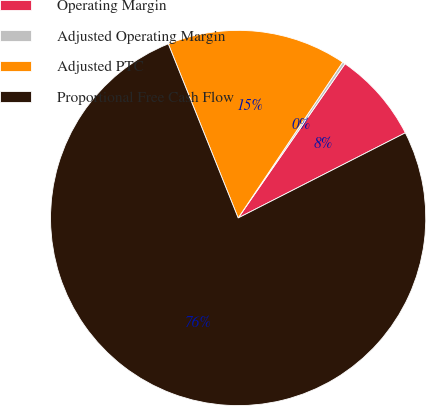Convert chart to OTSL. <chart><loc_0><loc_0><loc_500><loc_500><pie_chart><fcel>Operating Margin<fcel>Adjusted Operating Margin<fcel>Adjusted PTC<fcel>Proportional Free Cash Flow<nl><fcel>7.86%<fcel>0.24%<fcel>15.48%<fcel>76.43%<nl></chart> 